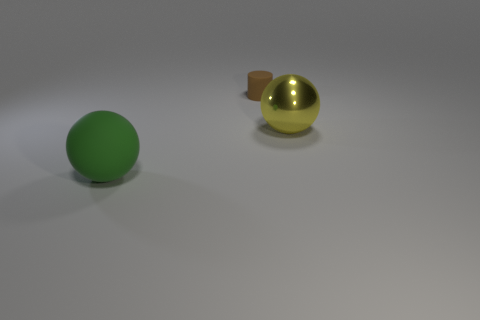Is there anything else that has the same material as the large yellow object?
Ensure brevity in your answer.  No. Is there any other thing that has the same size as the brown cylinder?
Ensure brevity in your answer.  No. Are the yellow thing and the small brown cylinder made of the same material?
Your answer should be compact. No. What number of yellow metal spheres are in front of the big object in front of the sphere behind the big green object?
Ensure brevity in your answer.  0. Is there another large yellow sphere that has the same material as the yellow sphere?
Provide a succinct answer. No. Are there fewer green matte balls than large spheres?
Make the answer very short. Yes. Does the big thing that is on the right side of the tiny cylinder have the same color as the large matte sphere?
Offer a terse response. No. What is the material of the large sphere that is to the left of the large ball right of the sphere left of the cylinder?
Keep it short and to the point. Rubber. Is there another rubber object of the same color as the small thing?
Give a very brief answer. No. Is the number of big metallic objects that are in front of the large matte thing less than the number of big yellow shiny objects?
Offer a very short reply. Yes. 